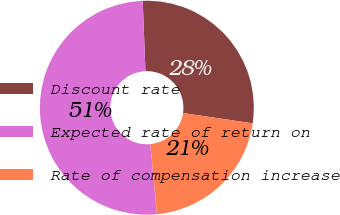<chart> <loc_0><loc_0><loc_500><loc_500><pie_chart><fcel>Discount rate<fcel>Expected rate of return on<fcel>Rate of compensation increase<nl><fcel>27.94%<fcel>50.9%<fcel>21.16%<nl></chart> 